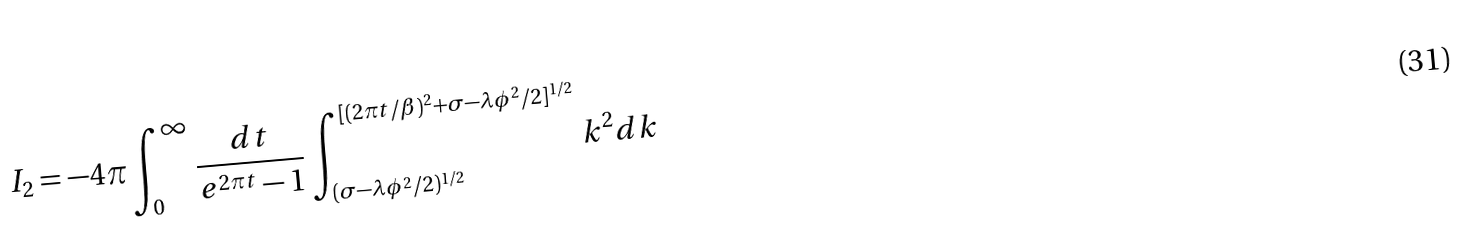<formula> <loc_0><loc_0><loc_500><loc_500>I _ { 2 } = - 4 \pi \int _ { 0 } ^ { \infty } \frac { d t } { e ^ { 2 \pi t } - 1 } \int _ { ( \sigma - \lambda \phi ^ { 2 } / 2 ) ^ { 1 / 2 } } ^ { [ ( 2 \pi t / \beta ) ^ { 2 } + \sigma - \lambda \phi ^ { 2 } / 2 ] ^ { 1 / 2 } } k ^ { 2 } d k</formula> 